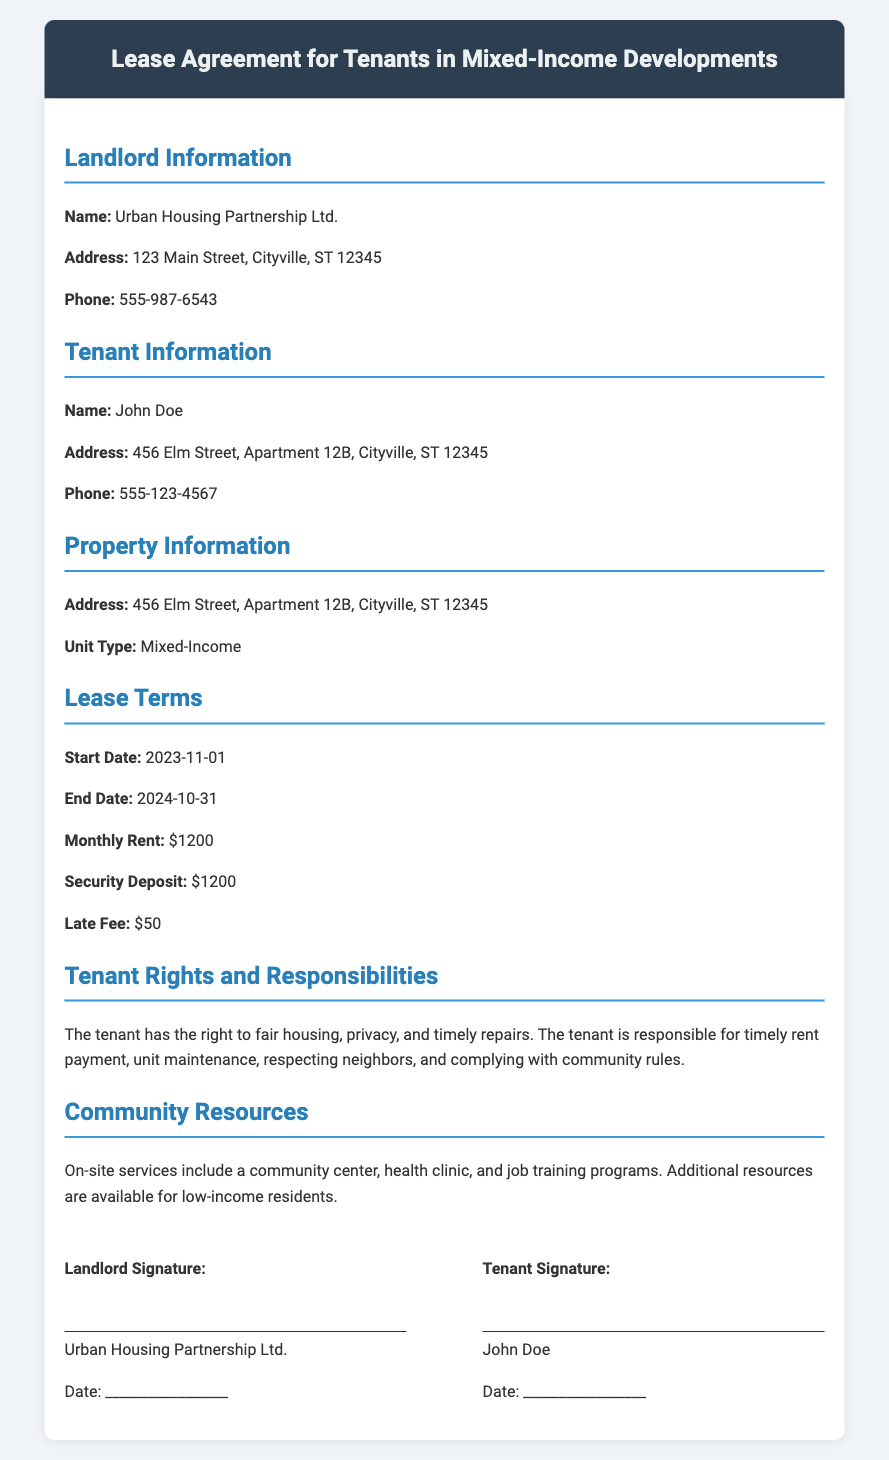What is the name of the landlord? The landlord's name is explicitly stated in the document.
Answer: Urban Housing Partnership Ltd What is the tenant's phone number? The tenant's phone number is provided in the Tenant Information section.
Answer: 555-123-4567 What is the monthly rent amount? The monthly rent amount is specified in the Lease Terms section.
Answer: $1200 What is the start date of the lease? The start date is given in the Lease Terms section of the document.
Answer: 2023-11-01 What community services are available on-site? The document lists community resources available on-site.
Answer: community center, health clinic, job training programs What is the late fee for delayed rent payment? The document specifies the late fee in the Lease Terms section.
Answer: $50 What are the tenant's responsibilities? The document outlines tenant responsibilities in a specific section.
Answer: timely rent payment, unit maintenance, respecting neighbors, complying with community rules What type of housing unit is this lease for? The Lease Terms section identifies the type of unit.
Answer: Mixed-Income What is the security deposit amount? The security deposit amount is detailed in the Lease Terms section.
Answer: $1200 Who must sign the lease agreement? The document specifies who needs to sign, indicating the parties involved.
Answer: Landlord and Tenant 